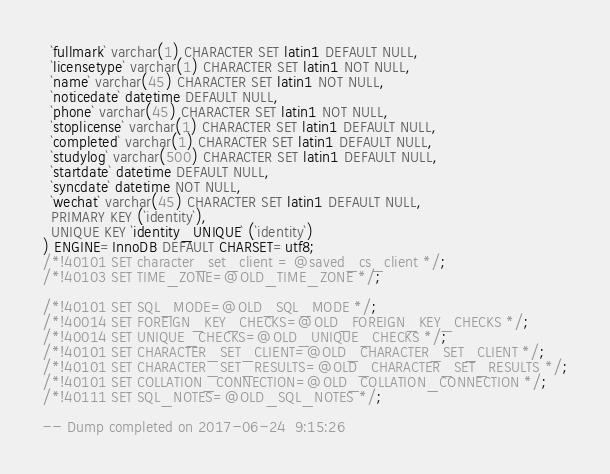<code> <loc_0><loc_0><loc_500><loc_500><_SQL_>  `fullmark` varchar(1) CHARACTER SET latin1 DEFAULT NULL,
  `licensetype` varchar(1) CHARACTER SET latin1 NOT NULL,
  `name` varchar(45) CHARACTER SET latin1 NOT NULL,
  `noticedate` datetime DEFAULT NULL,
  `phone` varchar(45) CHARACTER SET latin1 NOT NULL,
  `stoplicense` varchar(1) CHARACTER SET latin1 DEFAULT NULL,
  `completed` varchar(1) CHARACTER SET latin1 DEFAULT NULL,
  `studylog` varchar(500) CHARACTER SET latin1 DEFAULT NULL,
  `startdate` datetime DEFAULT NULL,
  `syncdate` datetime NOT NULL,
  `wechat` varchar(45) CHARACTER SET latin1 DEFAULT NULL,
  PRIMARY KEY (`identity`),
  UNIQUE KEY `identity_UNIQUE` (`identity`)
) ENGINE=InnoDB DEFAULT CHARSET=utf8;
/*!40101 SET character_set_client = @saved_cs_client */;
/*!40103 SET TIME_ZONE=@OLD_TIME_ZONE */;

/*!40101 SET SQL_MODE=@OLD_SQL_MODE */;
/*!40014 SET FOREIGN_KEY_CHECKS=@OLD_FOREIGN_KEY_CHECKS */;
/*!40014 SET UNIQUE_CHECKS=@OLD_UNIQUE_CHECKS */;
/*!40101 SET CHARACTER_SET_CLIENT=@OLD_CHARACTER_SET_CLIENT */;
/*!40101 SET CHARACTER_SET_RESULTS=@OLD_CHARACTER_SET_RESULTS */;
/*!40101 SET COLLATION_CONNECTION=@OLD_COLLATION_CONNECTION */;
/*!40111 SET SQL_NOTES=@OLD_SQL_NOTES */;

-- Dump completed on 2017-06-24  9:15:26
</code> 